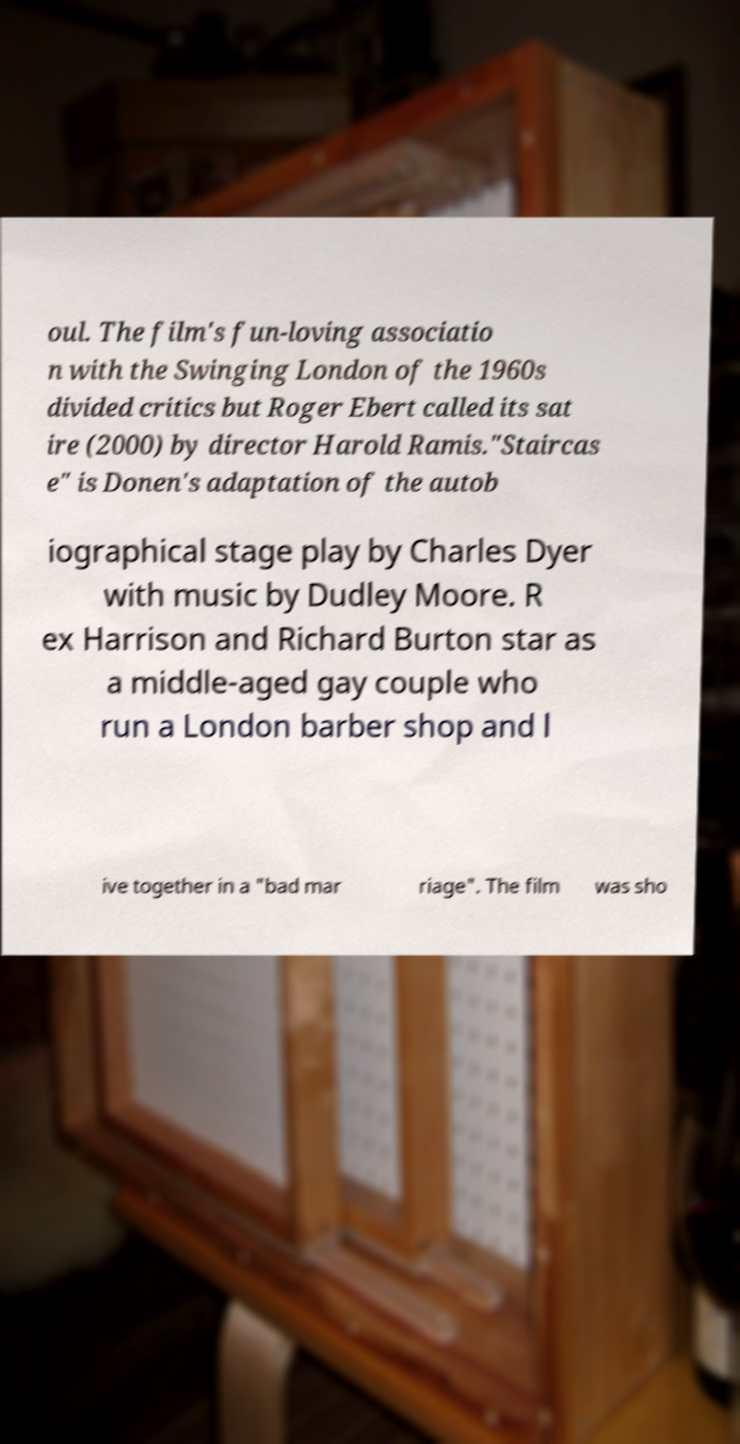Can you accurately transcribe the text from the provided image for me? oul. The film's fun-loving associatio n with the Swinging London of the 1960s divided critics but Roger Ebert called its sat ire (2000) by director Harold Ramis."Staircas e" is Donen's adaptation of the autob iographical stage play by Charles Dyer with music by Dudley Moore. R ex Harrison and Richard Burton star as a middle-aged gay couple who run a London barber shop and l ive together in a "bad mar riage". The film was sho 